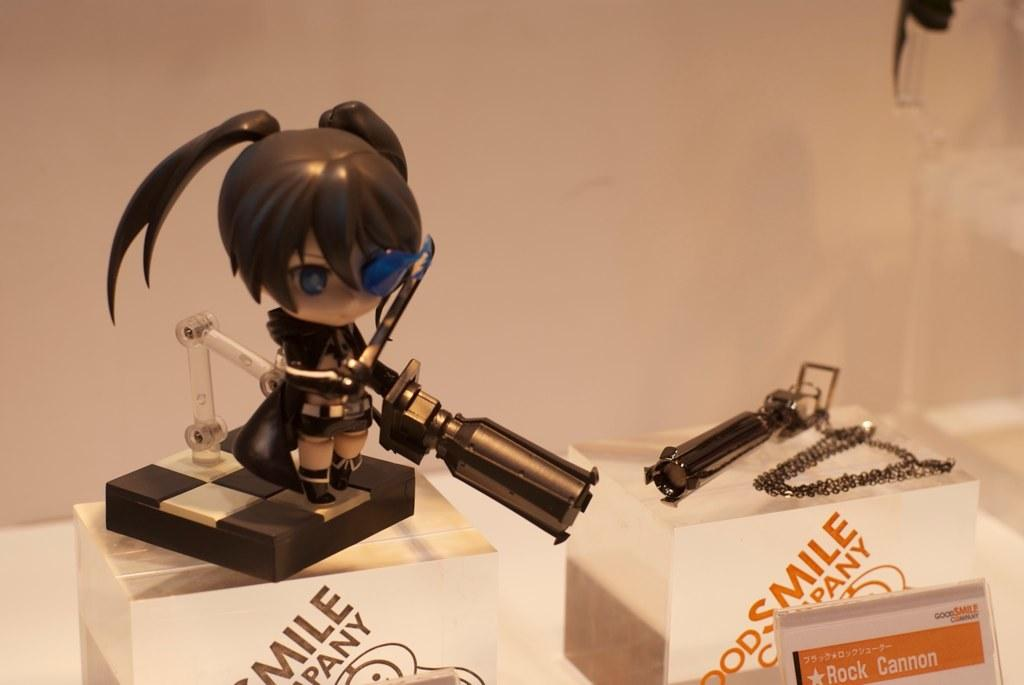What is the main subject of the image? The main subject of the image is an animated toy picture. Can you describe the toy in the picture? Unfortunately, the facts provided do not give any details about the toy itself. However, we can confirm that it is an animated toy. How does the animated toy in the image affect the thrill of the viewer's toe? There is no information about the viewer's toe or the toy's effect on it in the image or the provided facts. 